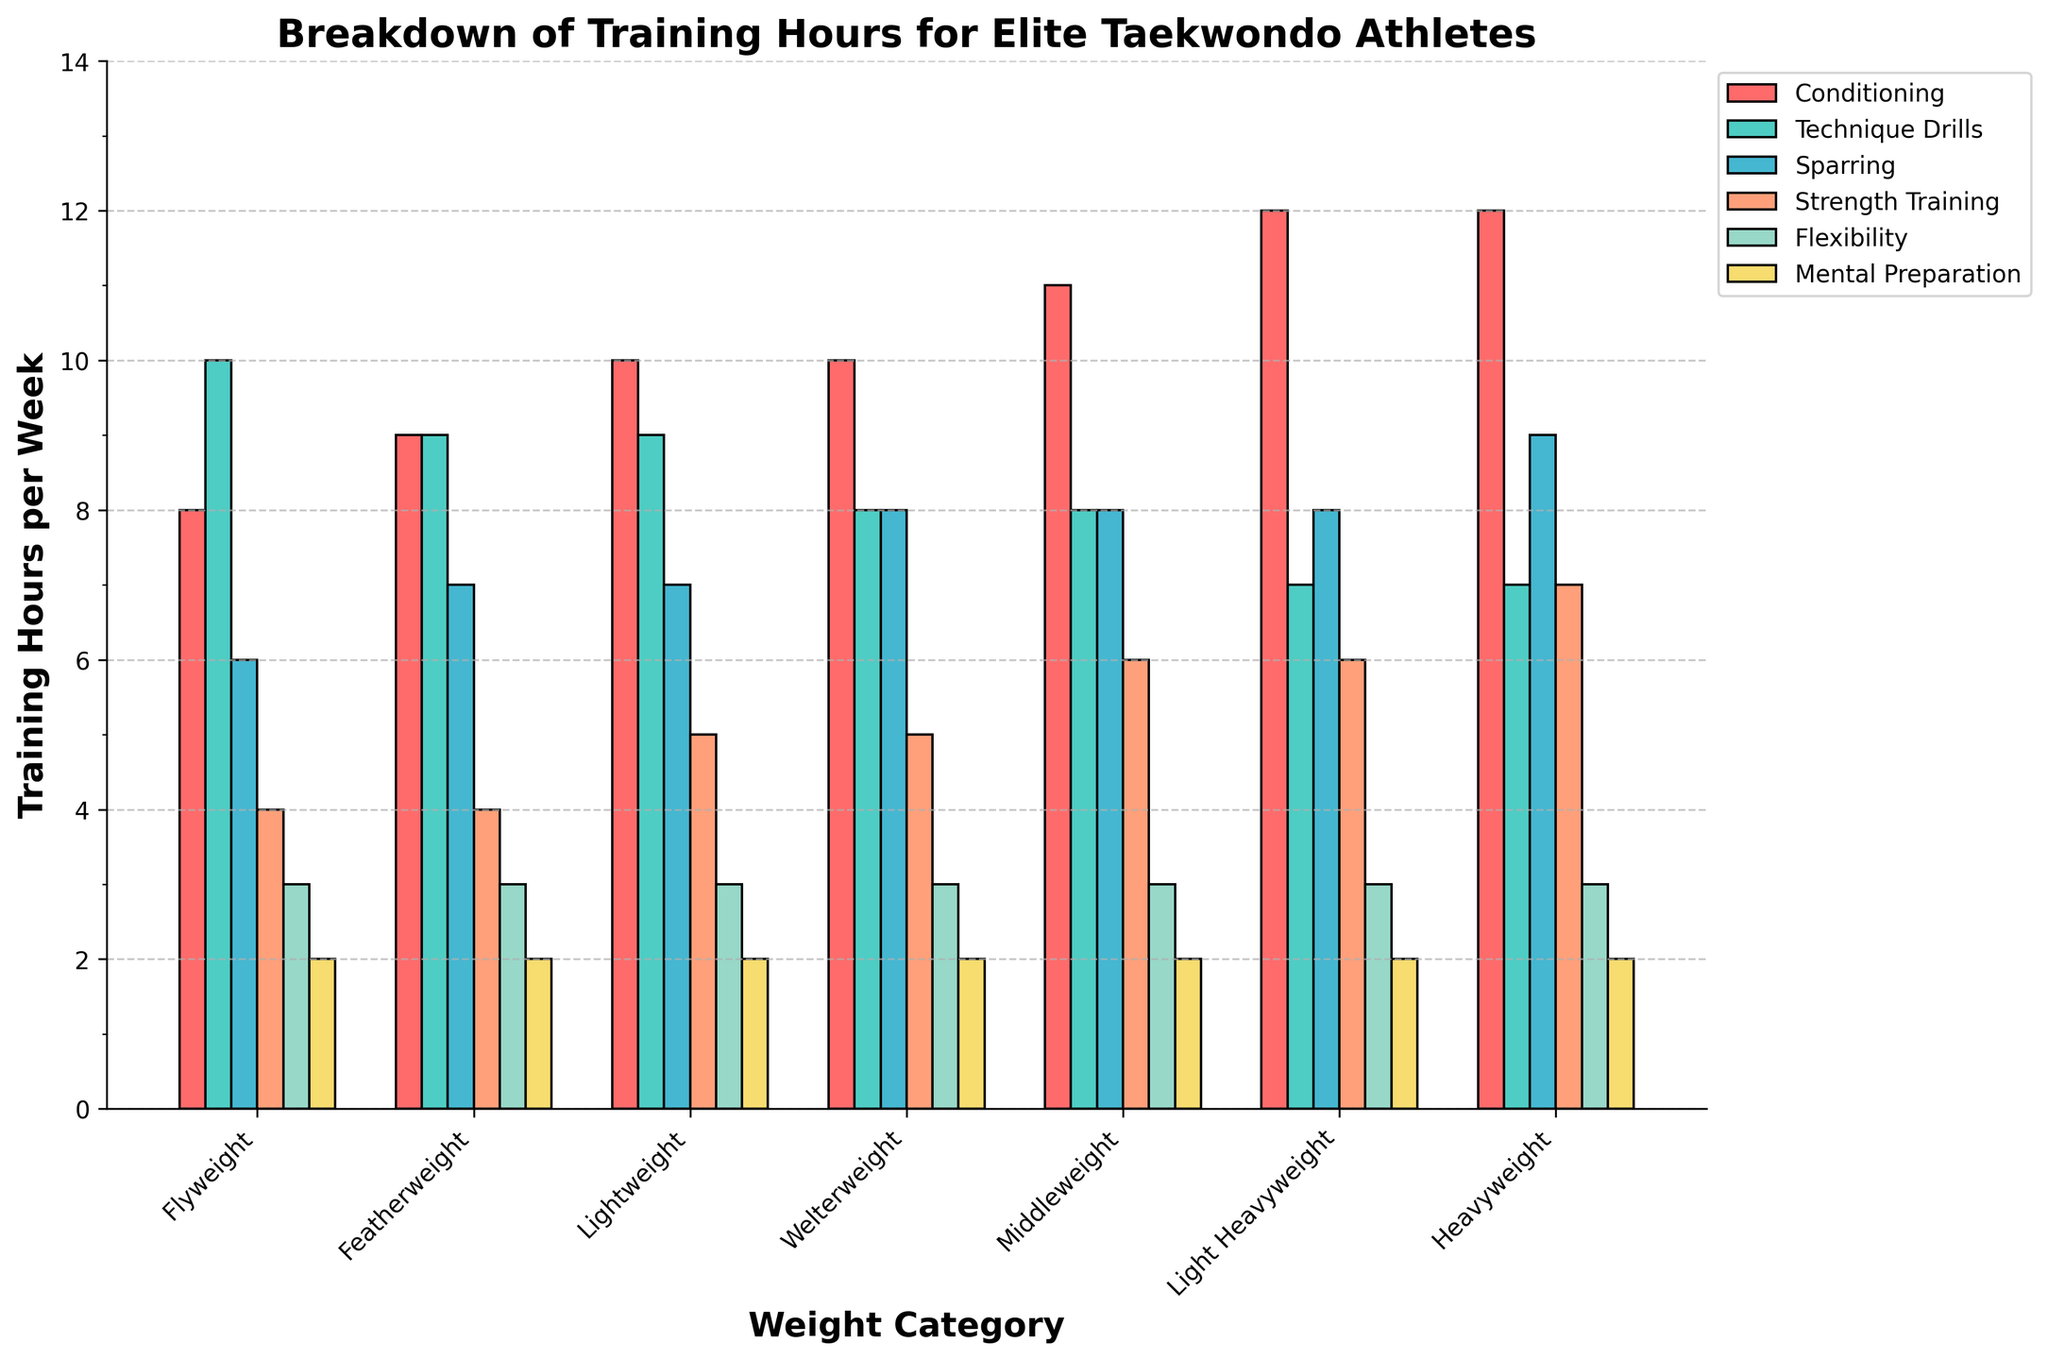What is the total amount of training hours per week for the Flyweight category? Sum all the training hours in the Flyweight row: 8 + 10 + 6 + 4 + 3 + 2 = 33
Answer: 33 Which weight category spends the most time on Conditioning? Look at the Conditioning bars for all weight categories and find the tallest one. The Heavyweight and Light Heavyweight both have the tallest bars at 12 hours.
Answer: Heavyweight and Light Heavyweight How many more hours do Middleweight athletes spend on Strength Training compared to Featherweight athletes? Subtract the Strength Training hours for Featherweight from the Strength Training hours for Middleweight: 6 - 4 = 2
Answer: 2 Which weight category spends the least amount of time on Technique Drills? Identify the shortest bar in the Technique Drills color (green). It is Light Heavyweight with 7 hours.
Answer: Light Heavyweight What is the average amount of time Welterweight athletes spend on Sparring and Mental Preparation combined? First, sum the Sparring and Mental Preparation hours for Welterweight: 8 + 2 = 10. Then, divide by 2 (number of activities) to get the average: 10 / 2 = 5
Answer: 5 By how much do Lightweight athletes exceed Flyweight athletes in Sparring hours? Subtract the Sparring hours for Flyweight from the Sparring hours for Lightweight: 7 - 6 = 1
Answer: 1 Which weight categories allocate the same amount of time for Flexibility training? Identify all the bars for Flexibility training that have the same height. All categories have 3 hours each.
Answer: All categories Which weight category has the longest combined training time for Conditioning and Strength Training? Sum the Conditioning and Strength Training hours for each category and find the maximum. Heavyweight: 12 + 7 = 19 Light Heavyweight: 12 + 6 = 18 Middleweight: 11 + 6 = 17 Welterweight: 10 + 5 = 15 Lightweight: 10 + 5 = 15 Featherweight: 9 + 4 = 13 Flyweight: 8 + 4 = 12 The highest total is for Heavyweight with 19 hours.
Answer: Heavyweight What is the difference in total weekly training time between Heavyweight and Flyweight categories? First calculate total training for Heavyweight: 12 (Conditioning) + 9 (Technique Drills) + 9 (Sparring) + 7 (Strength Training) + 3 (Flexibility) + 2 (Mental Preparation) = 42. Do the same for Flyweight: 8 + 10 + 6 + 4 + 3 + 2 = 33. Subtract the two totals: 42 - 33 = 9
Answer: 9 How many hours do Featherweight and Lightweight categories spend on Technique Drills combined? Add the Technique Drills hours for both Featherweight and Lightweight categories: 9 + 9 = 18
Answer: 18 